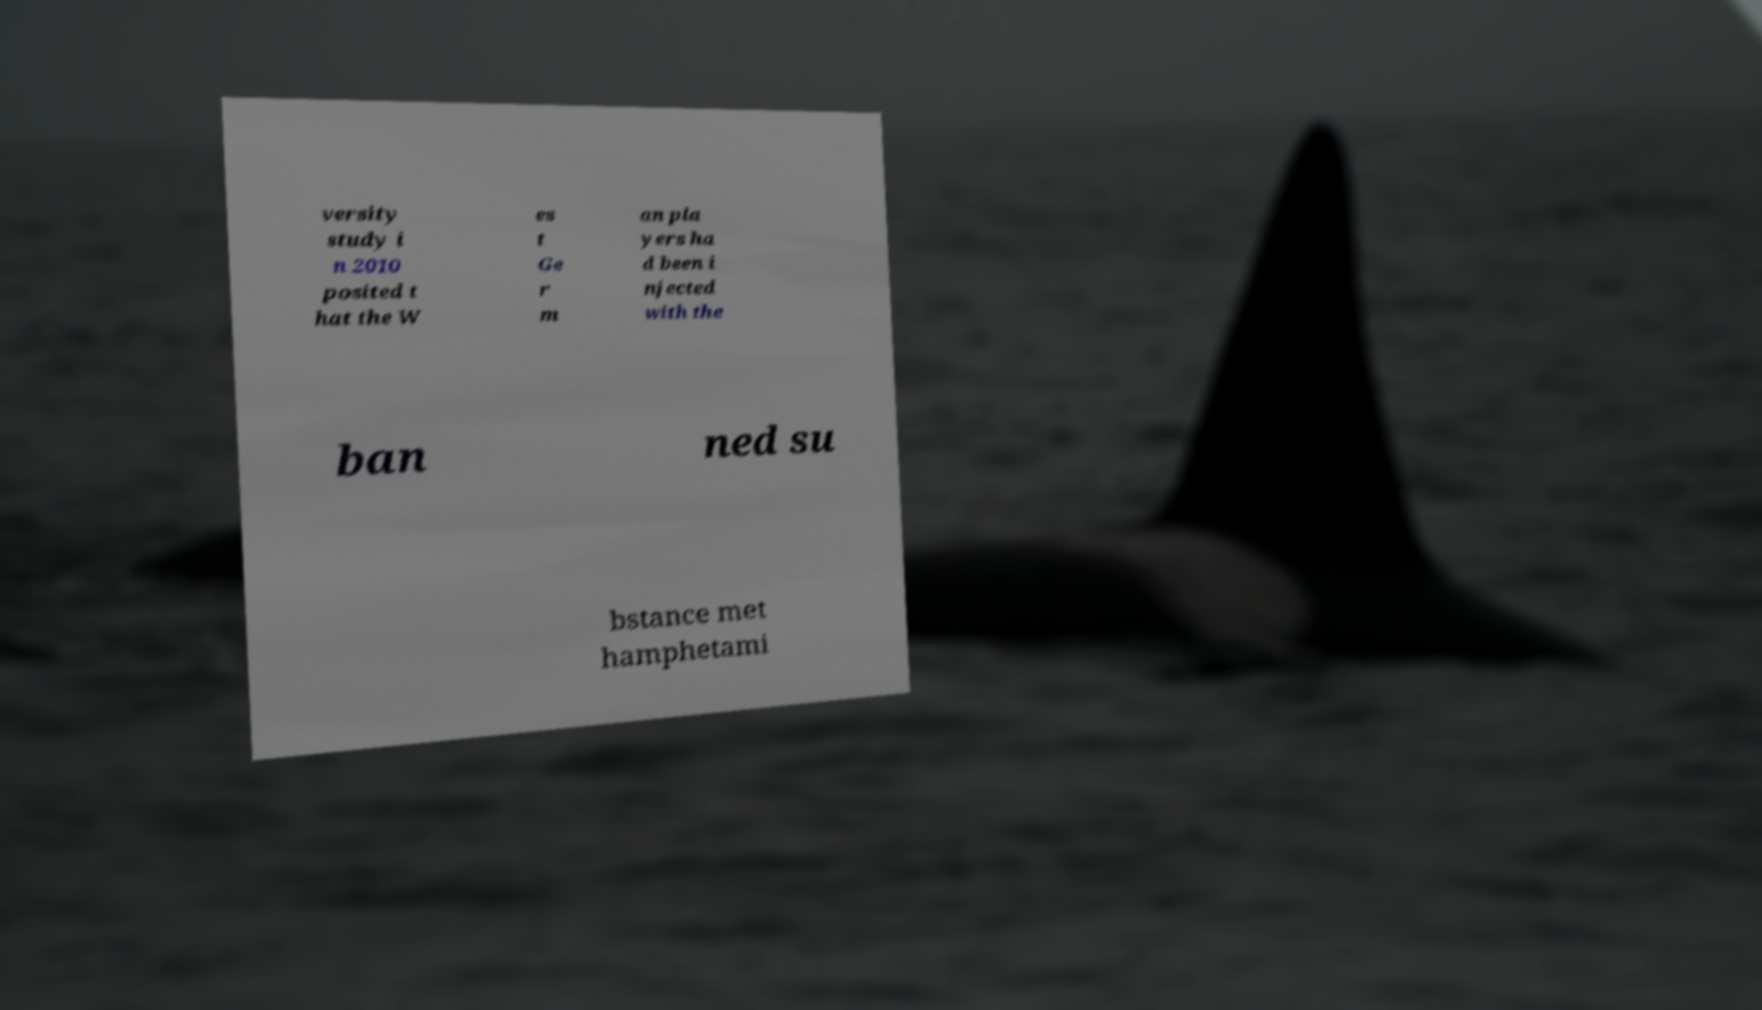I need the written content from this picture converted into text. Can you do that? versity study i n 2010 posited t hat the W es t Ge r m an pla yers ha d been i njected with the ban ned su bstance met hamphetami 